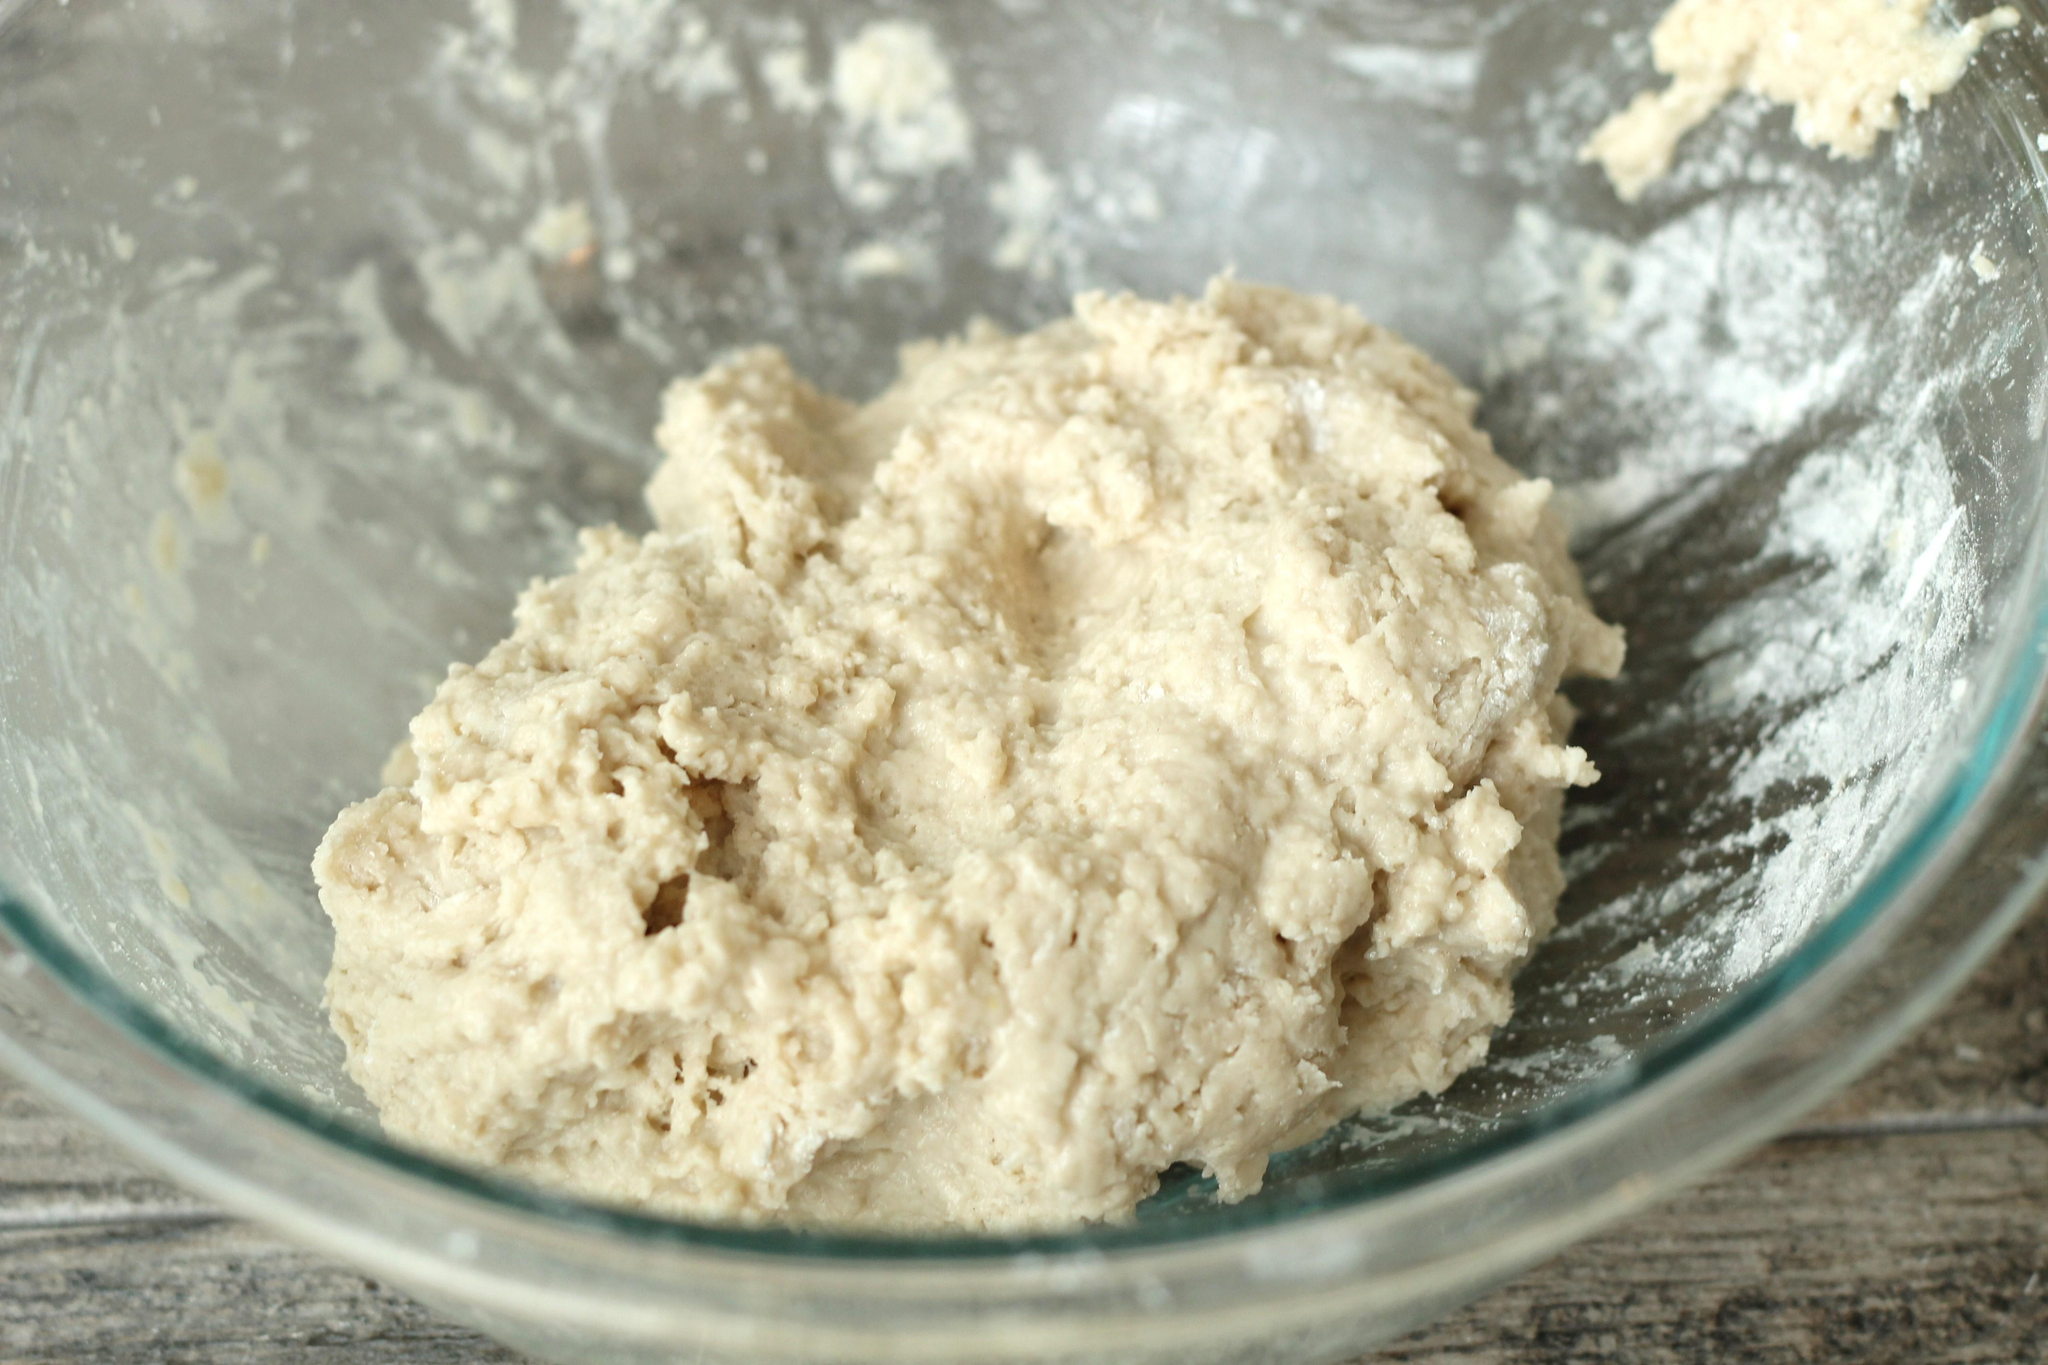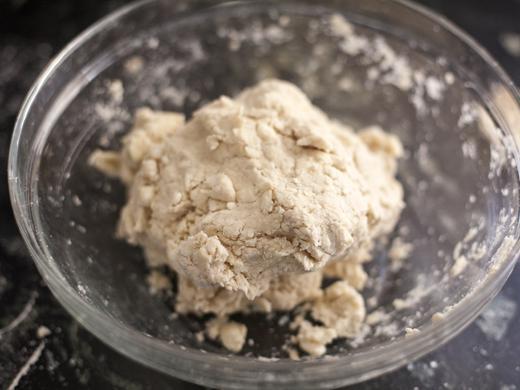The first image is the image on the left, the second image is the image on the right. Assess this claim about the two images: "There is a utensil in some dough.". Correct or not? Answer yes or no. No. The first image is the image on the left, the second image is the image on the right. For the images shown, is this caption "In at least one image there is a utenical in a silver mixing bowl." true? Answer yes or no. No. 